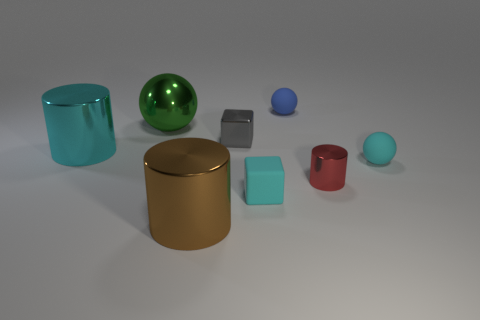What shape is the metallic thing that is left of the gray metal thing and right of the big green thing? The metallic object in question is a gold-colored cylinder. It's positioned to the left of the silver cube and to the right of the large green sphere, displaying a perfect cylindrical shape with its circular base parallel to the ground and a smooth, reflective surface. 